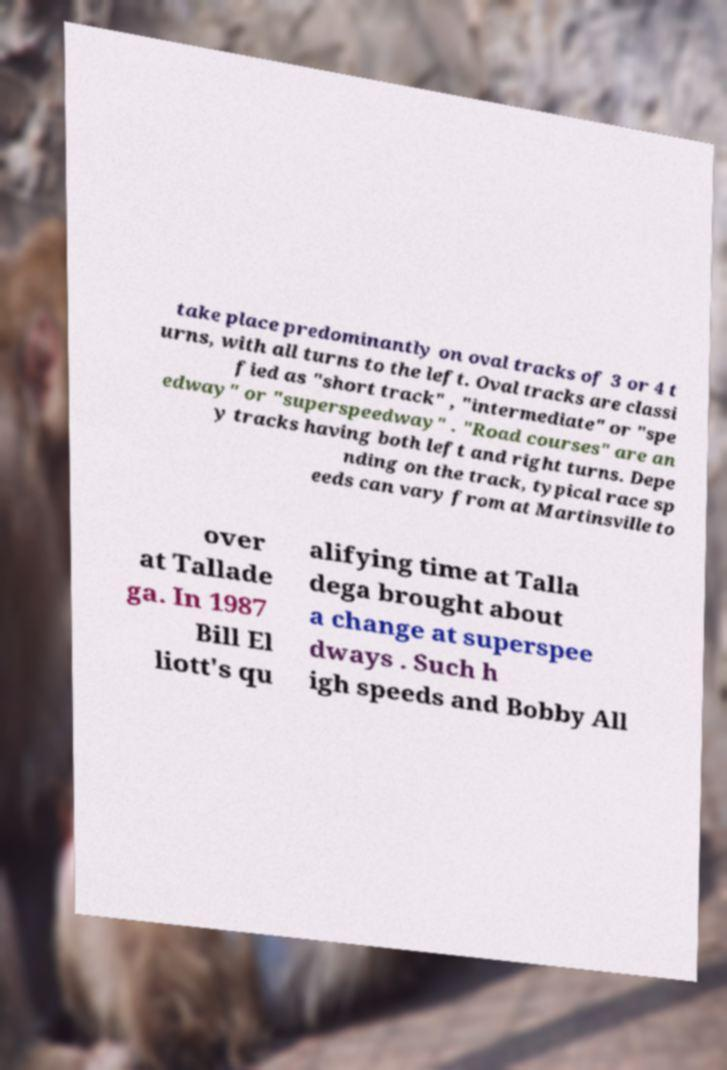I need the written content from this picture converted into text. Can you do that? take place predominantly on oval tracks of 3 or 4 t urns, with all turns to the left. Oval tracks are classi fied as "short track" , "intermediate" or "spe edway" or "superspeedway" . "Road courses" are an y tracks having both left and right turns. Depe nding on the track, typical race sp eeds can vary from at Martinsville to over at Tallade ga. In 1987 Bill El liott's qu alifying time at Talla dega brought about a change at superspee dways . Such h igh speeds and Bobby All 